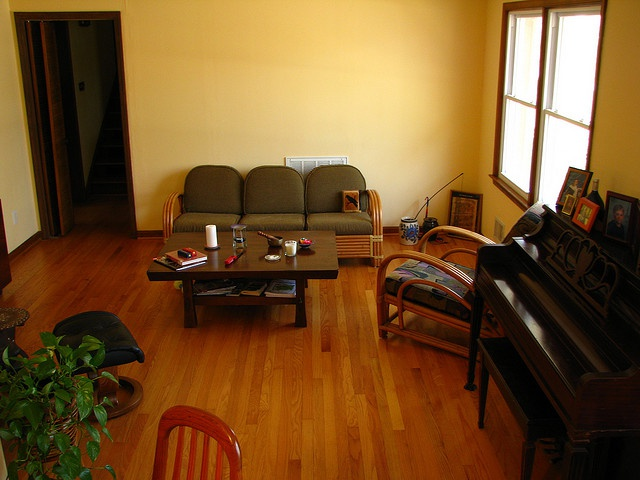Describe the objects in this image and their specific colors. I can see potted plant in tan, black, maroon, and darkgreen tones, couch in tan, maroon, black, olive, and brown tones, chair in tan, maroon, black, brown, and gray tones, chair in tan, maroon, and brown tones, and chair in tan, black, maroon, and darkgreen tones in this image. 